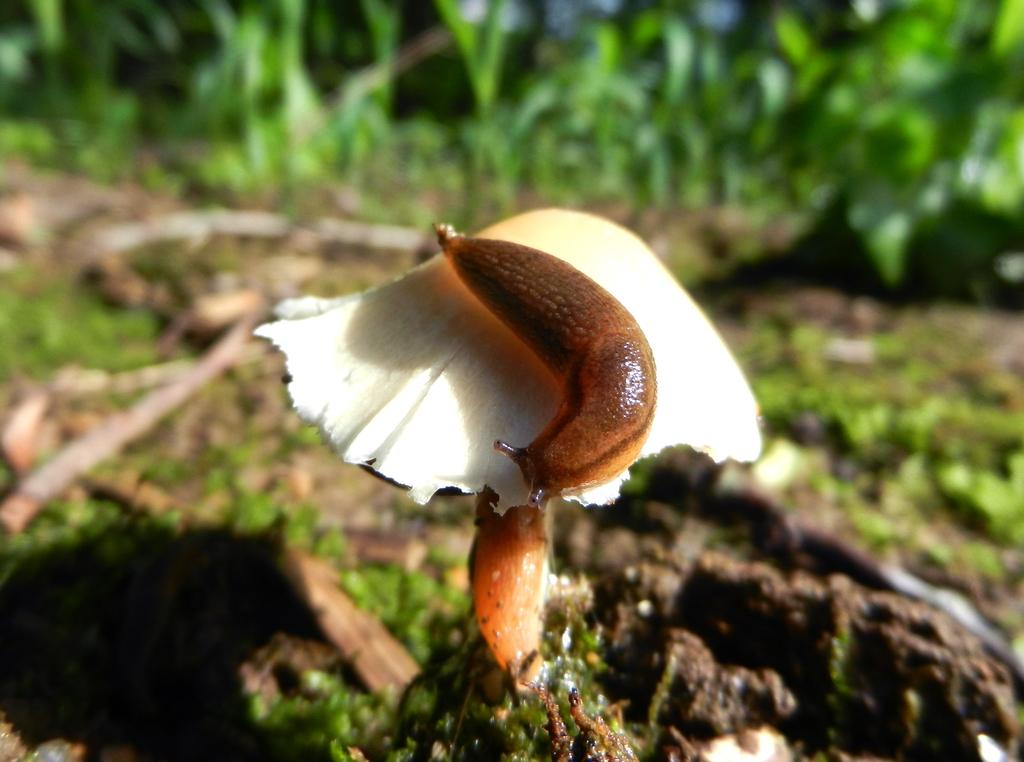What is the person in the image doing? The person is hiking in the mountains. Can you describe the location of the person in the image? The person is in the mountains. What might the person be experiencing while hiking in the mountains? The person might be enjoying the scenery, getting exercise, or experiencing a sense of adventure. How many rabbits can be seen in the image? There are no rabbits present in the image; it features a person hiking in the mountains. What type of loss is the person experiencing in the image? There is no indication of loss in the image; it shows a person hiking in the mountains. 